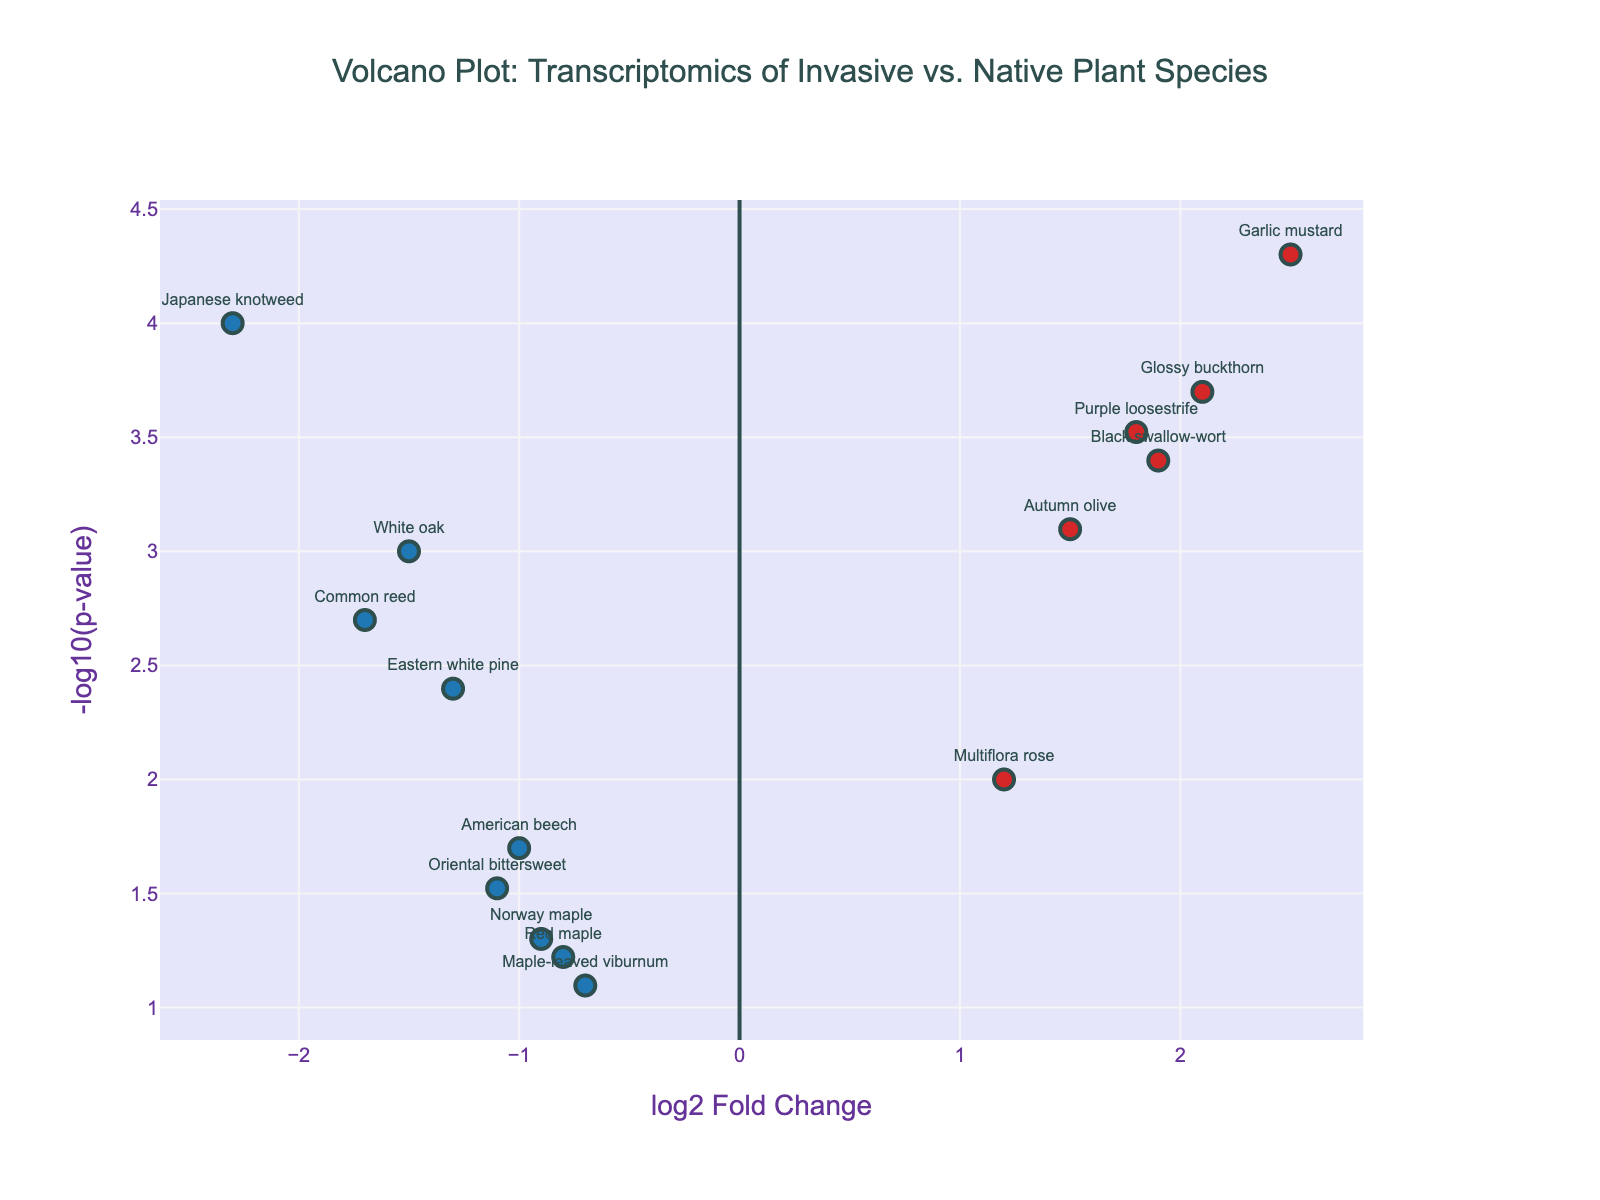What does the X-axis represent? The X-axis of the volcano plot represents the log2 fold change of gene expression, indicating how much a gene's expression level has increased or decreased.
Answer: log2 Fold Change What does the Y-axis represent? The Y-axis of the volcano plot represents the -log10(p-value), which indicates the statistical significance of the change in gene expression.
Answer: -log10(p-value) How many data points represent invasive plant species with upregulated genes (log2FoldChange > 0)? We count the number of data points where log2FoldChange is greater than zero. They are 5: Purple loosestrife, Garlic mustard, Multiflora rose, Autumn olive, Black swallow-wort, and Glossy buckthorn.
Answer: 6 Which gene has the highest log2 fold change? Looking at the X-axis, the gene with the highest log2 fold change is Garlic mustard.
Answer: Garlic mustard Which point represents American beech, and what are its log2 fold change and p-value? Look for the text label "American beech" near a negative log2 fold change on the X-axis, finding its position. The log2 fold change is -1.0, and the p-value is 0.02.
Answer: log2 fold change: -1.0, p-value: 0.02 Which gene is more statistically significant: White oak or American beech? Compare the -log10(p-value) for both genes on the Y-axis. White oak has a higher -log10(p-value), indicating higher statistical significance.
Answer: White oak Among the invasive plant species with downregulated genes, which one has the lowest statistical significance? Look at the data points for Japanese knotweed, Common reed, Norway maple, and Oriental bittersweet. Norway maple has the lowest -log10(p-value).
Answer: Norway maple How many genes have a p-value less than 0.001? To find the number of data points with a high statistical significance, we count those where -log10(p(value)) is greater than 3. They are Japanese knotweed, Purple loosestrife, Garlic mustard, Glossy buckthorn, and Black swallow-wort.
Answer: 5 Is there any gene with a log2 fold change around -1.1 and a significant p-value? Look for a data point near -1.1 on the X-axis and check its position on the Y-axis for significance. Oriental bittersweet has log2 fold change of -1.1 and p-value of 0.03 which is significant.
Answer: Oriental bittersweet Compare the statistical significance of the genes Autumn olive and Eastern white pine. Check the Y-axis positions for both genes. Autumn olive has a higher -log10(p-value) than Eastern white pine, meaning it is more statistically significant.
Answer: Autumn olive 